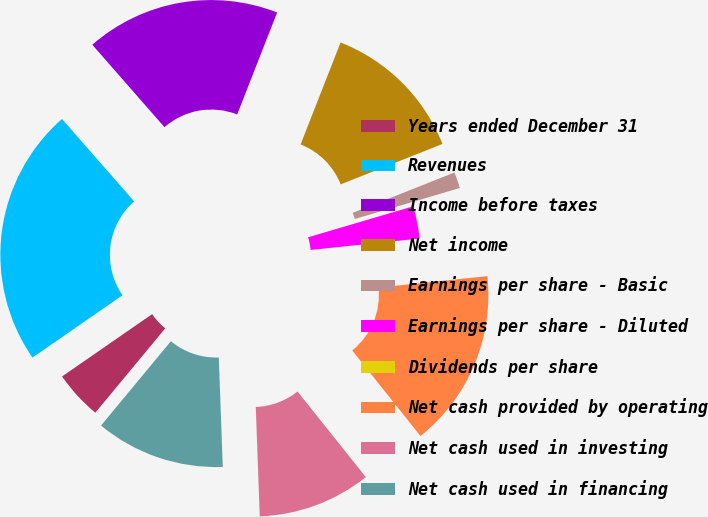Convert chart to OTSL. <chart><loc_0><loc_0><loc_500><loc_500><pie_chart><fcel>Years ended December 31<fcel>Revenues<fcel>Income before taxes<fcel>Net income<fcel>Earnings per share - Basic<fcel>Earnings per share - Diluted<fcel>Dividends per share<fcel>Net cash provided by operating<fcel>Net cash used in investing<fcel>Net cash used in financing<nl><fcel>4.35%<fcel>23.19%<fcel>17.39%<fcel>13.04%<fcel>1.45%<fcel>2.9%<fcel>0.0%<fcel>15.94%<fcel>10.14%<fcel>11.59%<nl></chart> 